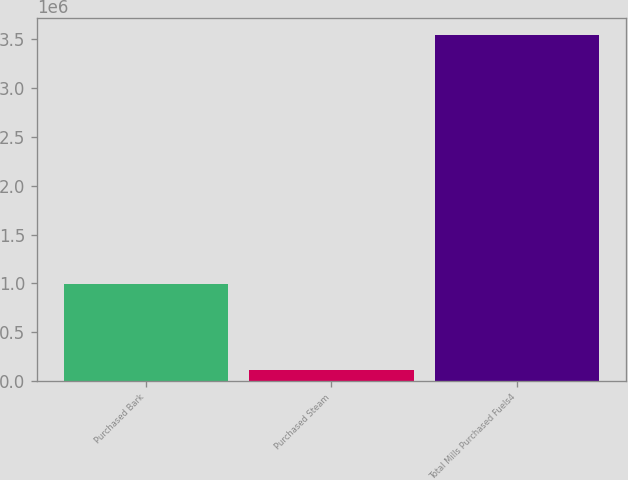Convert chart. <chart><loc_0><loc_0><loc_500><loc_500><bar_chart><fcel>Purchased Bark<fcel>Purchased Steam<fcel>Total Mills Purchased Fuels4<nl><fcel>991066<fcel>117459<fcel>3.54324e+06<nl></chart> 